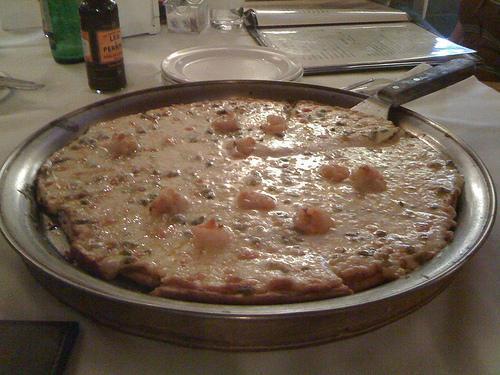How many bottles are in the picture?
Give a very brief answer. 2. How many people are there?
Give a very brief answer. 0. 